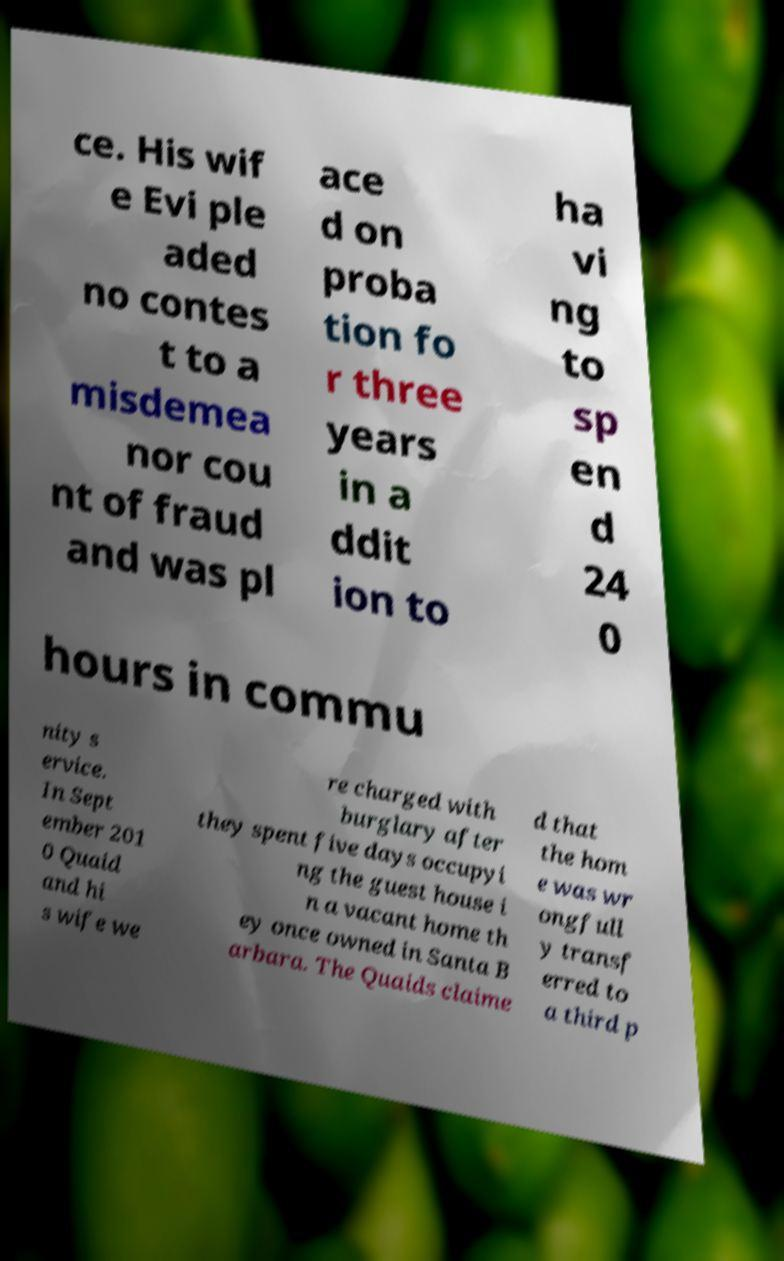What messages or text are displayed in this image? I need them in a readable, typed format. ce. His wif e Evi ple aded no contes t to a misdemea nor cou nt of fraud and was pl ace d on proba tion fo r three years in a ddit ion to ha vi ng to sp en d 24 0 hours in commu nity s ervice. In Sept ember 201 0 Quaid and hi s wife we re charged with burglary after they spent five days occupyi ng the guest house i n a vacant home th ey once owned in Santa B arbara. The Quaids claime d that the hom e was wr ongfull y transf erred to a third p 